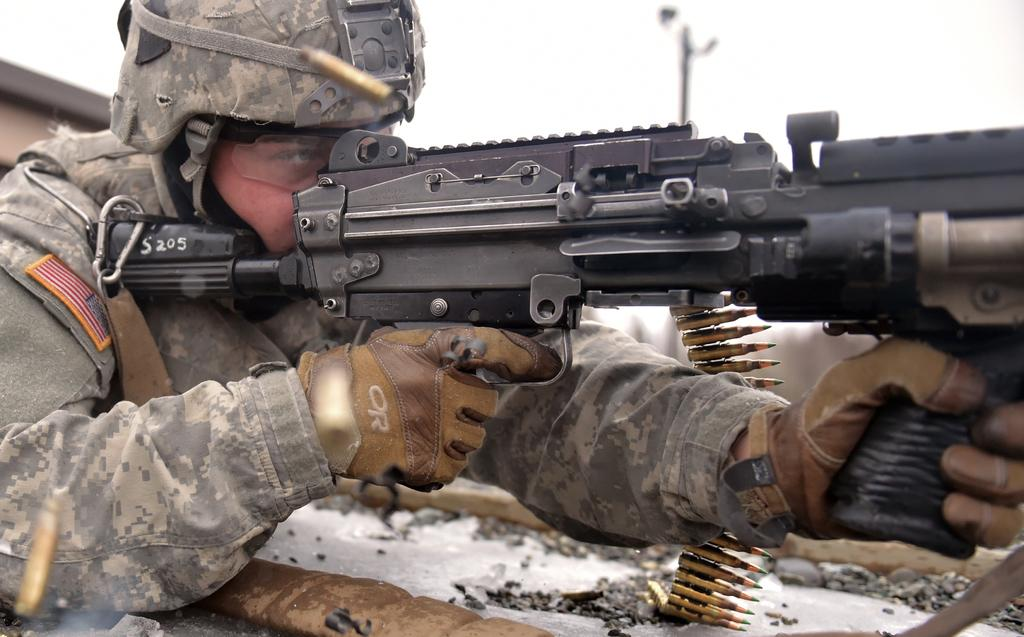What is the main subject of the image? There is a person in the image. What is the person holding in the image? The person is holding a gun and bullets. Can you describe the foreground of the image? The foreground area of the image is clear. How would you describe the background of the image? The background of the image is blurry. What type of stitch is being used to sew the border of the sand in the image? There is no stitch, border, or sand present in the image. 